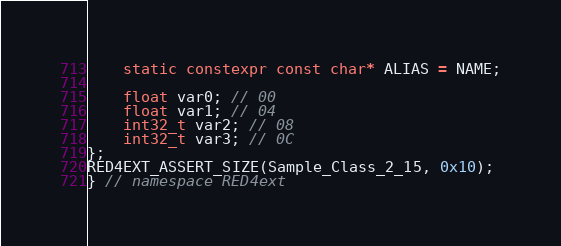<code> <loc_0><loc_0><loc_500><loc_500><_C++_>    static constexpr const char* ALIAS = NAME;

    float var0; // 00
    float var1; // 04
    int32_t var2; // 08
    int32_t var3; // 0C
};
RED4EXT_ASSERT_SIZE(Sample_Class_2_15, 0x10);
} // namespace RED4ext
</code> 